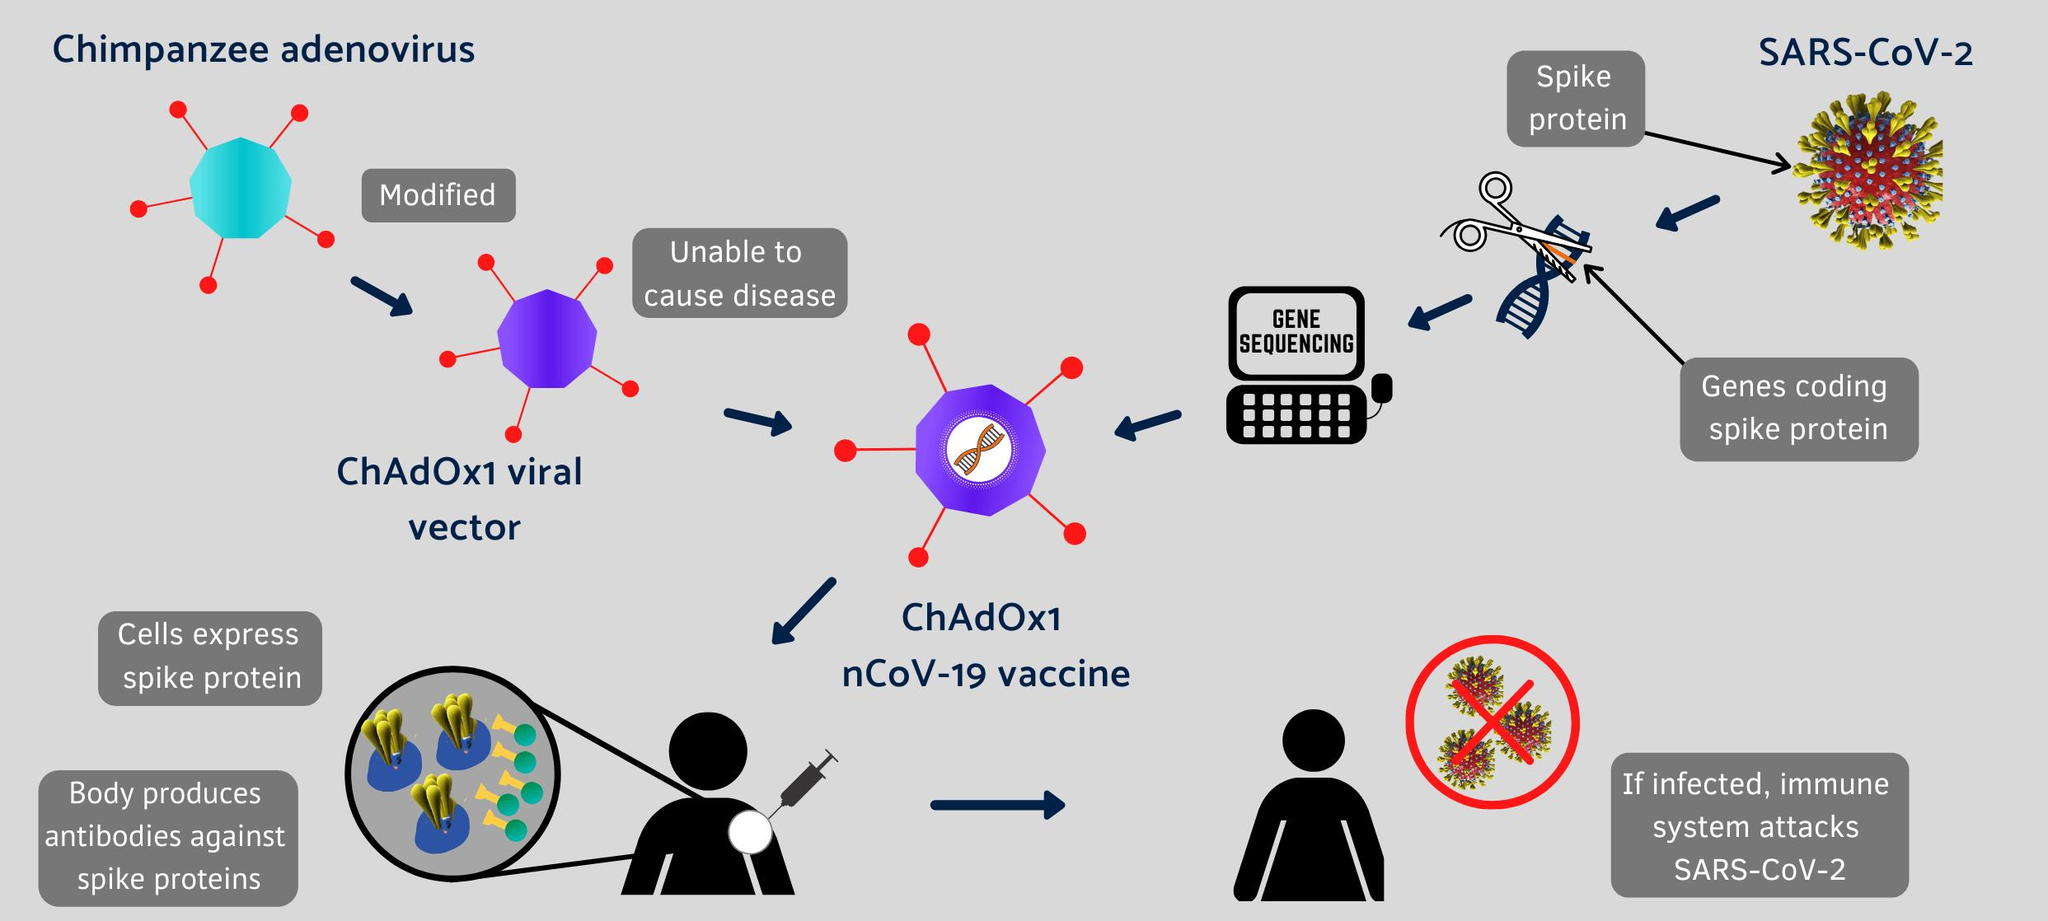Draw attention to some important aspects in this diagram. The ChAdOx1 nCoV-19 vaccine is effective in producing antibodies in the body to fight against spike proteins associated with the COVID-19 virus. ChAdOx1 viral vector is modified by adding genetic material from the ChAdOx1 chimpanzee adenovirus to create a new genetic construct for gene therapy. Gene sequencing is written on the computer screen. 